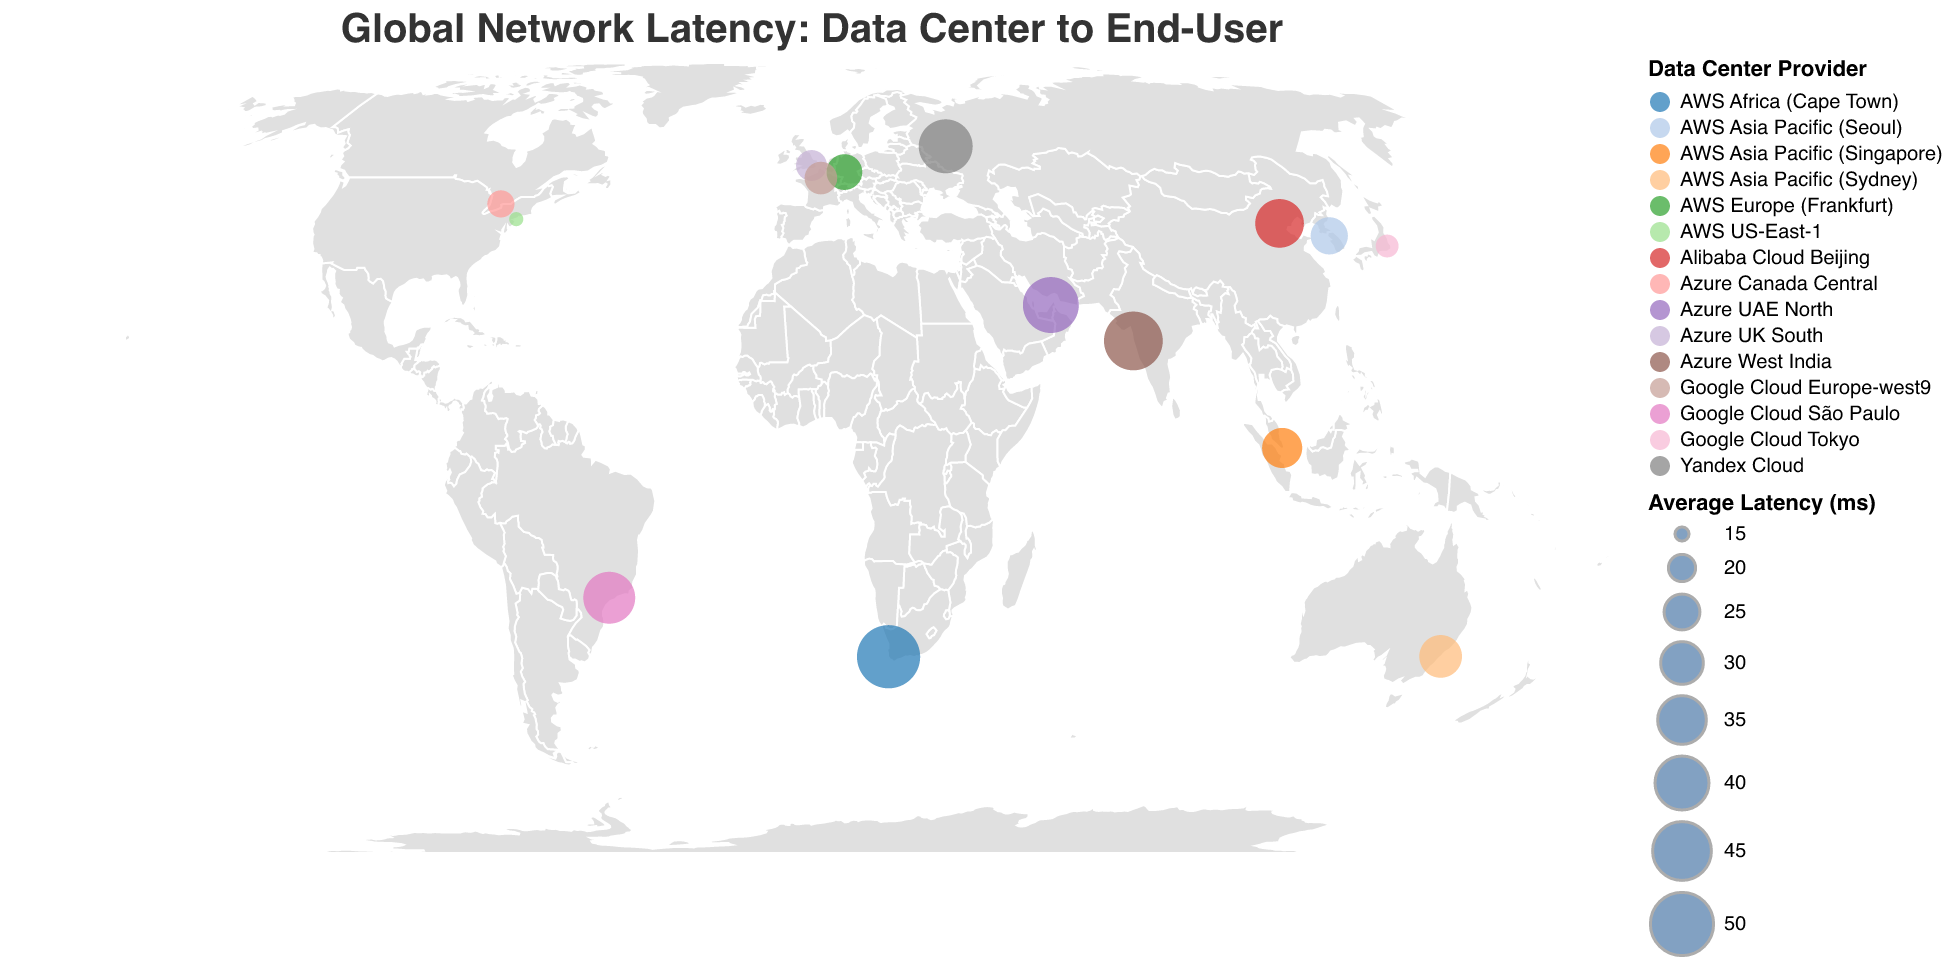How many data centers are displayed on the map? Count the number of circles representing data centers on the map.
Answer: 15 Which city has the highest network latency? Identify the city associated with the largest circle on the map. The size of the circle indicates the latency.
Answer: Cape Town What is the average latency for AWS data centers? Identify AWS data centers, sum their latencies, and calculate the average: (15 + 30 + 25 + 50 + 26 + 28) / 6.
Answer: 29 Is the latency in Mumbai higher or lower than in São Paulo? Compare the circle sizes for Mumbai and São Paulo: Mumbai has a larger circle, indicating higher latency.
Answer: Higher Which data center provider appears most frequently on the map? Count the occurrences of each data center provider in the legend.
Answer: AWS What is the range of latencies observed on the map? Identify the smallest and largest values of "Average Latency (ms)" displayed on the map. The smallest latency is 15 ms, and the largest is 50 ms. The range is 50 ms - 15 ms.
Answer: 35 ms Which city has the lowest network latency, and what is the value? Identify the city associated with the smallest circle on the map. The size of the circle indicates latency.
Answer: New York, 15 ms Are data centers in Asia generally having higher or lower latency compared to data centers in Europe? Compare latencies for cities in Asia (Tokyo, Mumbai, Singapore, Beijing, Seoul) against Europe (London, Frankfurt, Paris, Moscow). Average latency for Asia: (18 + 45 + 28 + 35 + 26) / 5 = 30.4 ms. Average latency for Europe: (22 + 25 + 23 + 40) / 4 = 27.5 ms. Asia has a higher average latency.
Answer: Higher Which two cities have latencies closest to each other? Find pairs of cities with latencies that are numerically close together (e.g., 1-2 ms difference). Compare: New York (15) and Tokyo (18) with a difference of 3 ms. London (22) and Paris (23) with a difference of 1 ms. The smallest difference is between London and Paris.
Answer: London and Paris What is the total latency for Google Cloud data centers? Identify Google Cloud data centers, and sum their latencies: 18 (Tokyo) + 38 (São Paulo) + 23 (Paris) = 79 ms.
Answer: 79 ms 